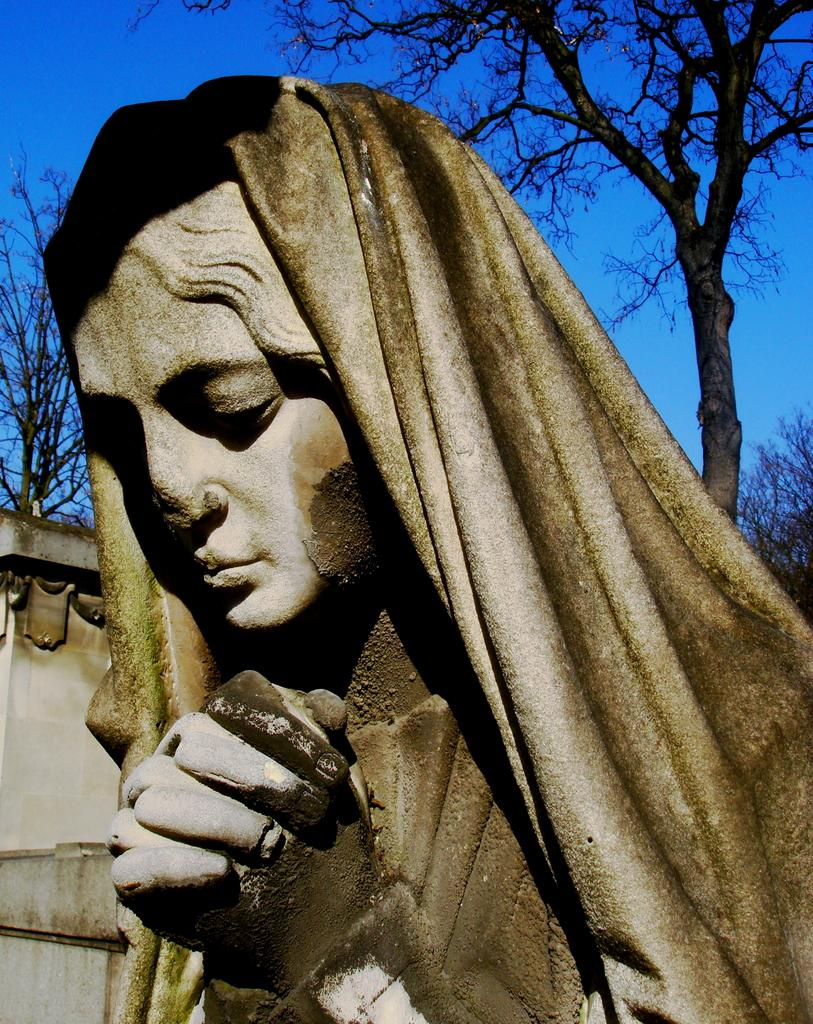What is the main subject of the image? There is a sculpture of a woman in the image. What is the sculpture holding or wearing? The sculpture has a cloth. What type of natural elements can be seen in the image? There are trees visible in the image. What type of man-made structure is present in the image? There is a wall in the image. What type of stitch is used to create the calendar in the image? There is no calendar present in the image, and therefore no stitch can be observed. 